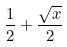<formula> <loc_0><loc_0><loc_500><loc_500>\frac { 1 } { 2 } + \frac { \sqrt { x } } { 2 }</formula> 